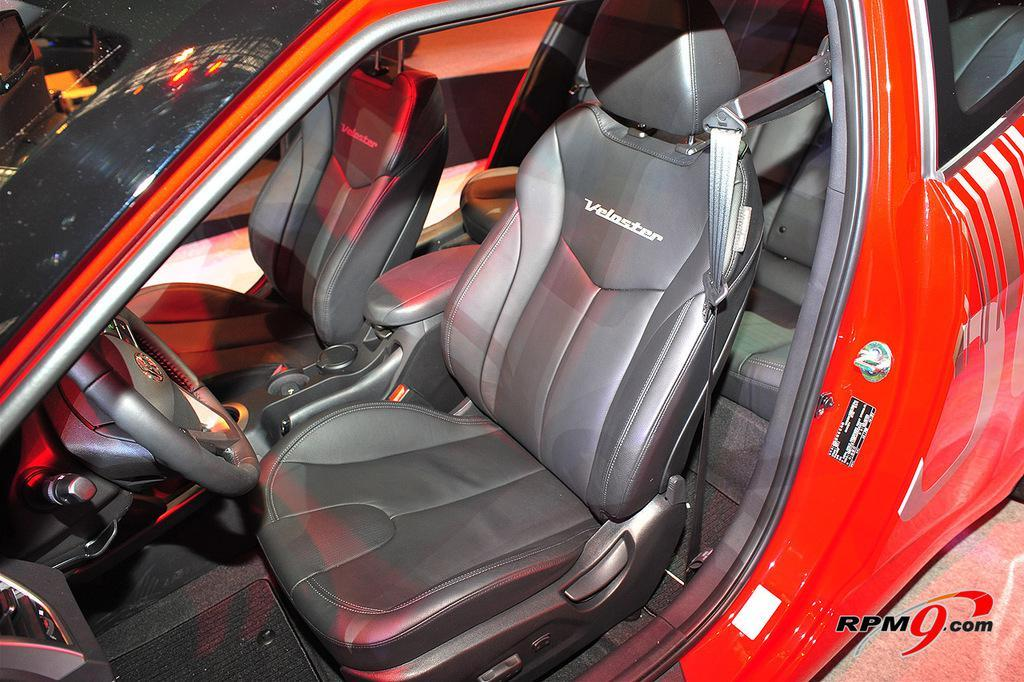What color is the car in the image? The car in the image is red. What parts of the car can be seen in the image? The front seats and the steering wheel of the car are visible in the image. Can you describe the position of the steering wheel in the image? The steering wheel is visible in the image, indicating that the car is likely facing the viewer. How many heads of lettuce are visible in the image? There are no heads of lettuce present in the image. What type of change is being made to the car in the image? There is no indication of any changes being made to the car in the image. 